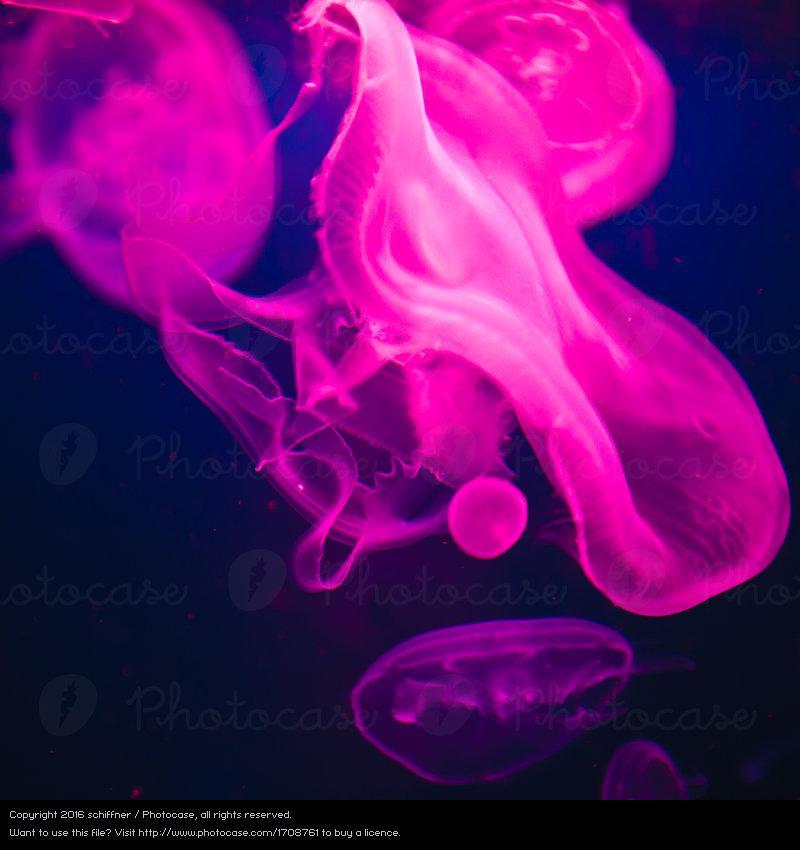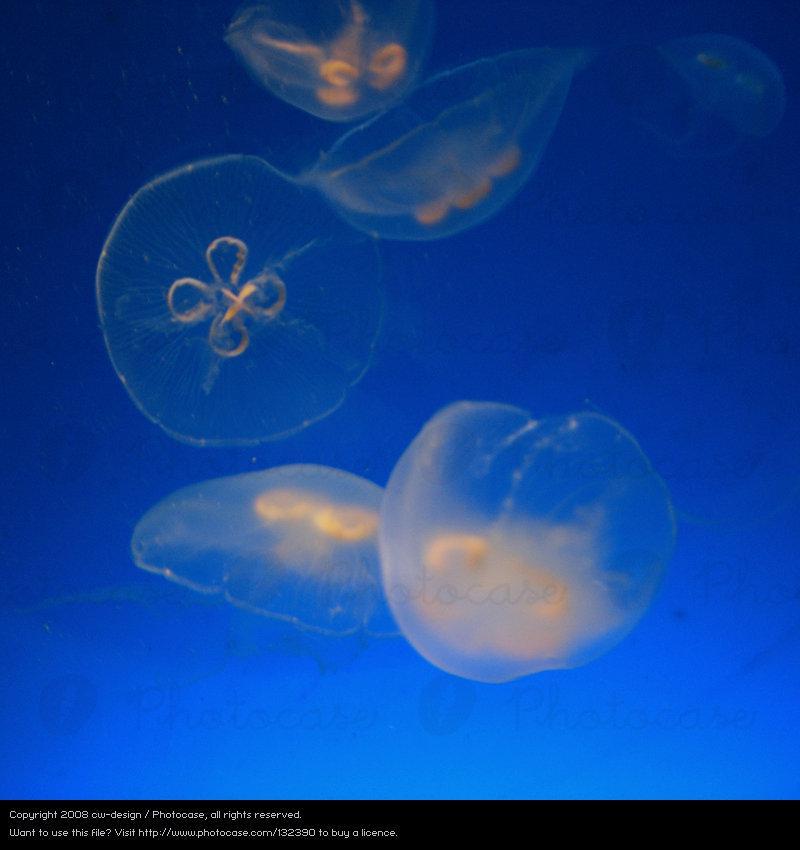The first image is the image on the left, the second image is the image on the right. Evaluate the accuracy of this statement regarding the images: "Exactly one image shows multiple hot pink jellyfish on a blue backdrop.". Is it true? Answer yes or no. Yes. The first image is the image on the left, the second image is the image on the right. For the images shown, is this caption "There is a single upright jellyfish in one of the images." true? Answer yes or no. No. 